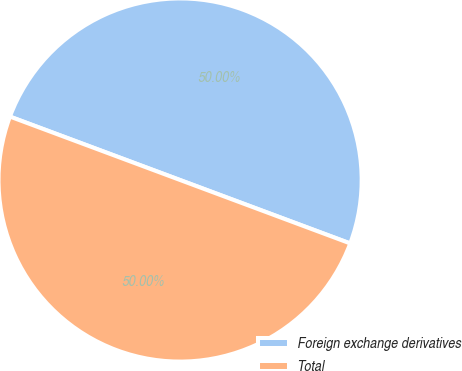Convert chart to OTSL. <chart><loc_0><loc_0><loc_500><loc_500><pie_chart><fcel>Foreign exchange derivatives<fcel>Total<nl><fcel>50.0%<fcel>50.0%<nl></chart> 